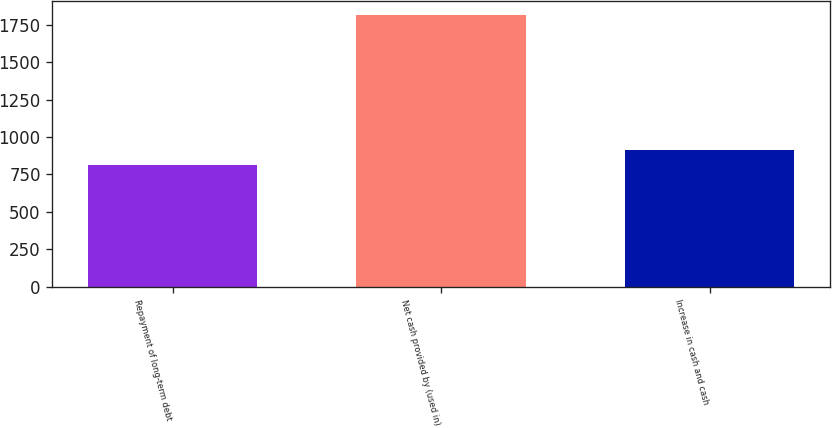Convert chart to OTSL. <chart><loc_0><loc_0><loc_500><loc_500><bar_chart><fcel>Repayment of long-term debt<fcel>Net cash provided by (used in)<fcel>Increase in cash and cash<nl><fcel>812<fcel>1818<fcel>912.6<nl></chart> 